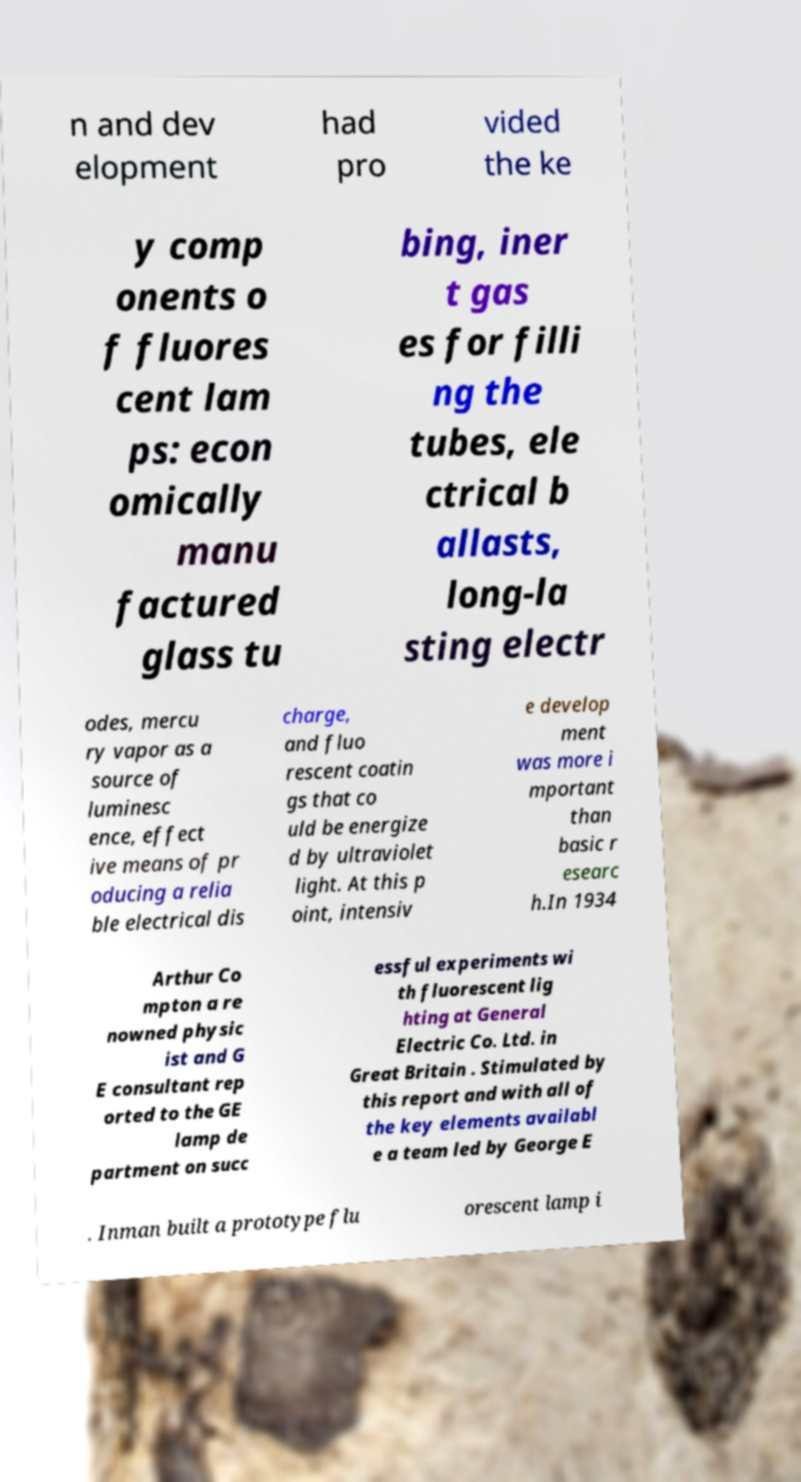Please identify and transcribe the text found in this image. n and dev elopment had pro vided the ke y comp onents o f fluores cent lam ps: econ omically manu factured glass tu bing, iner t gas es for filli ng the tubes, ele ctrical b allasts, long-la sting electr odes, mercu ry vapor as a source of luminesc ence, effect ive means of pr oducing a relia ble electrical dis charge, and fluo rescent coatin gs that co uld be energize d by ultraviolet light. At this p oint, intensiv e develop ment was more i mportant than basic r esearc h.In 1934 Arthur Co mpton a re nowned physic ist and G E consultant rep orted to the GE lamp de partment on succ essful experiments wi th fluorescent lig hting at General Electric Co. Ltd. in Great Britain . Stimulated by this report and with all of the key elements availabl e a team led by George E . Inman built a prototype flu orescent lamp i 